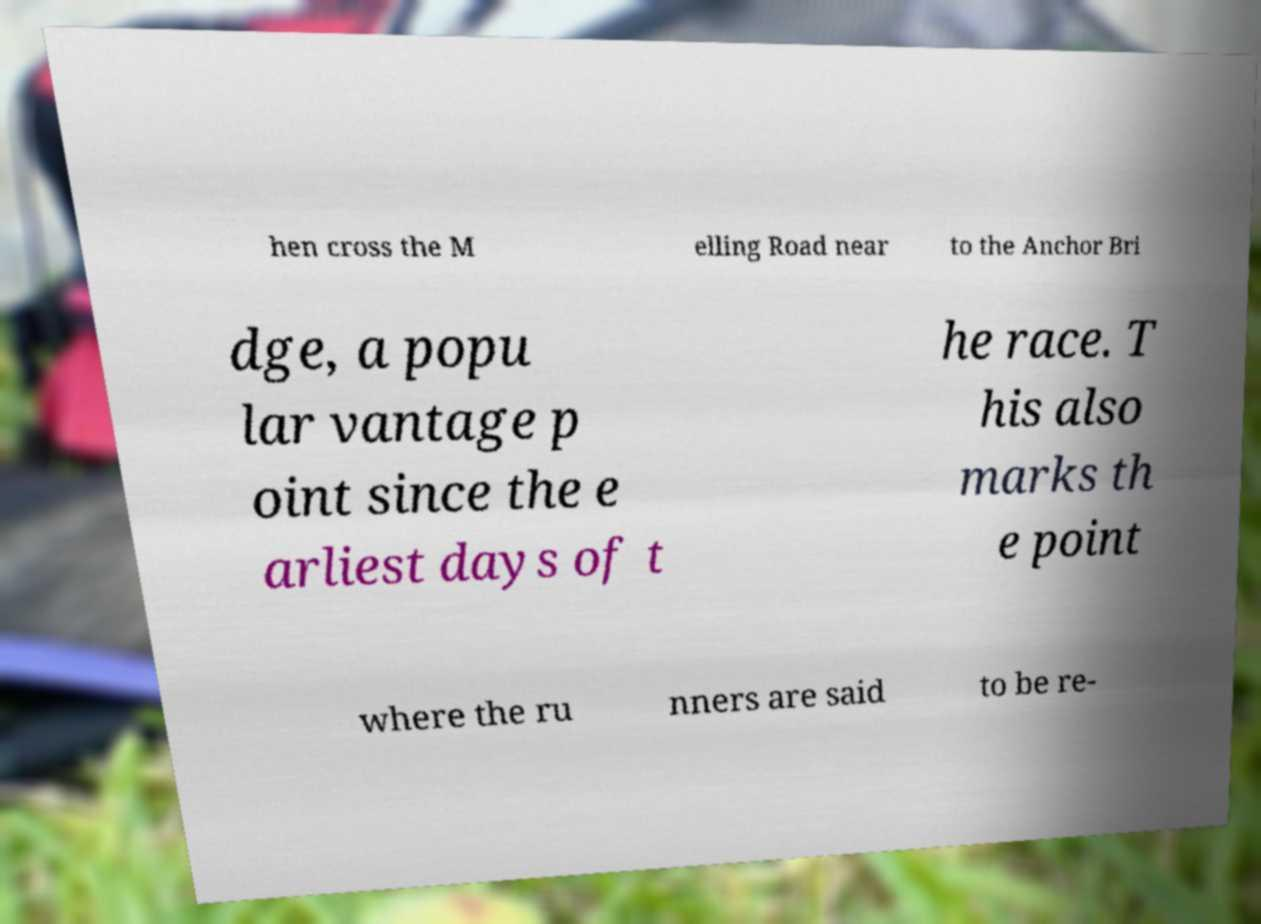There's text embedded in this image that I need extracted. Can you transcribe it verbatim? hen cross the M elling Road near to the Anchor Bri dge, a popu lar vantage p oint since the e arliest days of t he race. T his also marks th e point where the ru nners are said to be re- 